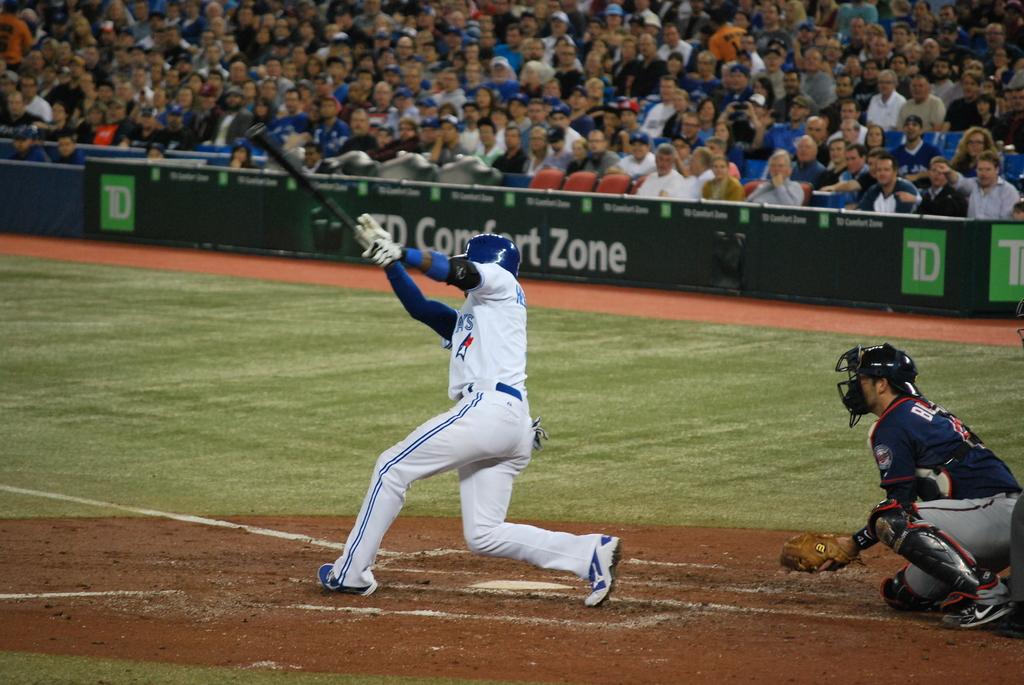Is this game sponsored by td?
Ensure brevity in your answer.  Yes. What is the first letter on the back of the catcher's jersey?
Your answer should be compact. B. 